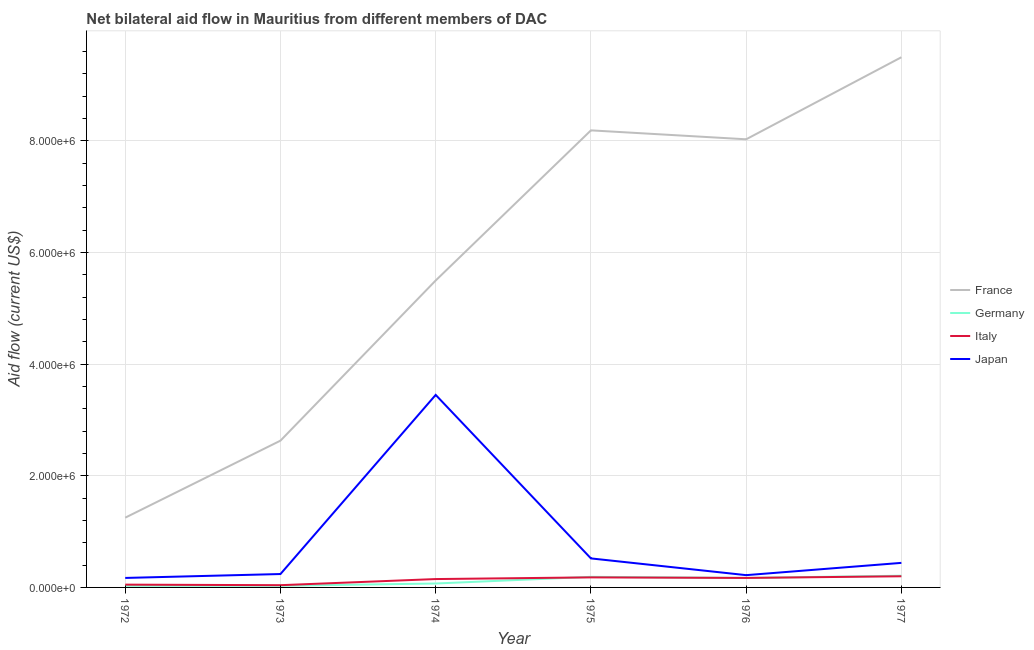How many different coloured lines are there?
Offer a very short reply. 4. What is the amount of aid given by france in 1974?
Your response must be concise. 5.50e+06. Across all years, what is the maximum amount of aid given by italy?
Your answer should be very brief. 2.00e+05. Across all years, what is the minimum amount of aid given by italy?
Your answer should be very brief. 4.00e+04. What is the total amount of aid given by france in the graph?
Ensure brevity in your answer.  3.51e+07. What is the difference between the amount of aid given by japan in 1972 and that in 1975?
Provide a short and direct response. -3.50e+05. What is the difference between the amount of aid given by italy in 1972 and the amount of aid given by germany in 1976?
Your answer should be compact. -1.20e+05. What is the average amount of aid given by germany per year?
Offer a very short reply. 1.17e+05. In the year 1973, what is the difference between the amount of aid given by germany and amount of aid given by italy?
Provide a succinct answer. -10000. In how many years, is the amount of aid given by germany greater than 6800000 US$?
Offer a very short reply. 0. What is the ratio of the amount of aid given by france in 1976 to that in 1977?
Ensure brevity in your answer.  0.85. Is the amount of aid given by france in 1976 less than that in 1977?
Keep it short and to the point. Yes. Is the difference between the amount of aid given by germany in 1972 and 1975 greater than the difference between the amount of aid given by japan in 1972 and 1975?
Keep it short and to the point. Yes. What is the difference between the highest and the second highest amount of aid given by france?
Offer a very short reply. 1.31e+06. What is the difference between the highest and the lowest amount of aid given by japan?
Make the answer very short. 3.28e+06. In how many years, is the amount of aid given by japan greater than the average amount of aid given by japan taken over all years?
Provide a succinct answer. 1. Is it the case that in every year, the sum of the amount of aid given by japan and amount of aid given by italy is greater than the sum of amount of aid given by france and amount of aid given by germany?
Offer a terse response. No. Is it the case that in every year, the sum of the amount of aid given by france and amount of aid given by germany is greater than the amount of aid given by italy?
Your response must be concise. Yes. Does the amount of aid given by italy monotonically increase over the years?
Keep it short and to the point. No. How many lines are there?
Ensure brevity in your answer.  4. How many years are there in the graph?
Provide a succinct answer. 6. Are the values on the major ticks of Y-axis written in scientific E-notation?
Your answer should be very brief. Yes. Does the graph contain any zero values?
Make the answer very short. No. Does the graph contain grids?
Give a very brief answer. Yes. How are the legend labels stacked?
Offer a terse response. Vertical. What is the title of the graph?
Ensure brevity in your answer.  Net bilateral aid flow in Mauritius from different members of DAC. What is the Aid flow (current US$) in France in 1972?
Keep it short and to the point. 1.25e+06. What is the Aid flow (current US$) in Germany in 1972?
Provide a short and direct response. 3.00e+04. What is the Aid flow (current US$) in Italy in 1972?
Make the answer very short. 5.00e+04. What is the Aid flow (current US$) of Japan in 1972?
Provide a succinct answer. 1.70e+05. What is the Aid flow (current US$) in France in 1973?
Make the answer very short. 2.63e+06. What is the Aid flow (current US$) in Germany in 1973?
Give a very brief answer. 3.00e+04. What is the Aid flow (current US$) in France in 1974?
Ensure brevity in your answer.  5.50e+06. What is the Aid flow (current US$) in Japan in 1974?
Give a very brief answer. 3.45e+06. What is the Aid flow (current US$) in France in 1975?
Your answer should be compact. 8.19e+06. What is the Aid flow (current US$) in Italy in 1975?
Offer a terse response. 1.80e+05. What is the Aid flow (current US$) in Japan in 1975?
Your response must be concise. 5.20e+05. What is the Aid flow (current US$) in France in 1976?
Provide a succinct answer. 8.03e+06. What is the Aid flow (current US$) in Japan in 1976?
Offer a very short reply. 2.20e+05. What is the Aid flow (current US$) in France in 1977?
Offer a terse response. 9.50e+06. What is the Aid flow (current US$) of Germany in 1977?
Ensure brevity in your answer.  2.10e+05. Across all years, what is the maximum Aid flow (current US$) of France?
Offer a terse response. 9.50e+06. Across all years, what is the maximum Aid flow (current US$) in Germany?
Make the answer very short. 2.10e+05. Across all years, what is the maximum Aid flow (current US$) in Italy?
Your answer should be very brief. 2.00e+05. Across all years, what is the maximum Aid flow (current US$) of Japan?
Provide a short and direct response. 3.45e+06. Across all years, what is the minimum Aid flow (current US$) of France?
Offer a terse response. 1.25e+06. Across all years, what is the minimum Aid flow (current US$) of Italy?
Offer a terse response. 4.00e+04. What is the total Aid flow (current US$) of France in the graph?
Provide a succinct answer. 3.51e+07. What is the total Aid flow (current US$) of Italy in the graph?
Make the answer very short. 7.90e+05. What is the total Aid flow (current US$) in Japan in the graph?
Provide a short and direct response. 5.04e+06. What is the difference between the Aid flow (current US$) of France in 1972 and that in 1973?
Keep it short and to the point. -1.38e+06. What is the difference between the Aid flow (current US$) in Italy in 1972 and that in 1973?
Make the answer very short. 10000. What is the difference between the Aid flow (current US$) in Japan in 1972 and that in 1973?
Make the answer very short. -7.00e+04. What is the difference between the Aid flow (current US$) of France in 1972 and that in 1974?
Your response must be concise. -4.25e+06. What is the difference between the Aid flow (current US$) of Japan in 1972 and that in 1974?
Ensure brevity in your answer.  -3.28e+06. What is the difference between the Aid flow (current US$) in France in 1972 and that in 1975?
Your answer should be compact. -6.94e+06. What is the difference between the Aid flow (current US$) in Japan in 1972 and that in 1975?
Offer a terse response. -3.50e+05. What is the difference between the Aid flow (current US$) of France in 1972 and that in 1976?
Provide a short and direct response. -6.78e+06. What is the difference between the Aid flow (current US$) of Germany in 1972 and that in 1976?
Offer a very short reply. -1.40e+05. What is the difference between the Aid flow (current US$) in Italy in 1972 and that in 1976?
Keep it short and to the point. -1.20e+05. What is the difference between the Aid flow (current US$) of France in 1972 and that in 1977?
Offer a very short reply. -8.25e+06. What is the difference between the Aid flow (current US$) in France in 1973 and that in 1974?
Your answer should be compact. -2.87e+06. What is the difference between the Aid flow (current US$) in Japan in 1973 and that in 1974?
Your answer should be very brief. -3.21e+06. What is the difference between the Aid flow (current US$) in France in 1973 and that in 1975?
Your answer should be compact. -5.56e+06. What is the difference between the Aid flow (current US$) in Japan in 1973 and that in 1975?
Offer a very short reply. -2.80e+05. What is the difference between the Aid flow (current US$) in France in 1973 and that in 1976?
Ensure brevity in your answer.  -5.40e+06. What is the difference between the Aid flow (current US$) of Italy in 1973 and that in 1976?
Offer a terse response. -1.30e+05. What is the difference between the Aid flow (current US$) in France in 1973 and that in 1977?
Ensure brevity in your answer.  -6.87e+06. What is the difference between the Aid flow (current US$) in Japan in 1973 and that in 1977?
Your answer should be compact. -2.00e+05. What is the difference between the Aid flow (current US$) in France in 1974 and that in 1975?
Offer a terse response. -2.69e+06. What is the difference between the Aid flow (current US$) of Germany in 1974 and that in 1975?
Keep it short and to the point. -1.20e+05. What is the difference between the Aid flow (current US$) of Japan in 1974 and that in 1975?
Keep it short and to the point. 2.93e+06. What is the difference between the Aid flow (current US$) of France in 1974 and that in 1976?
Your response must be concise. -2.53e+06. What is the difference between the Aid flow (current US$) in Germany in 1974 and that in 1976?
Provide a short and direct response. -1.00e+05. What is the difference between the Aid flow (current US$) in Japan in 1974 and that in 1976?
Provide a short and direct response. 3.23e+06. What is the difference between the Aid flow (current US$) in France in 1974 and that in 1977?
Provide a succinct answer. -4.00e+06. What is the difference between the Aid flow (current US$) of Italy in 1974 and that in 1977?
Provide a short and direct response. -5.00e+04. What is the difference between the Aid flow (current US$) in Japan in 1974 and that in 1977?
Give a very brief answer. 3.01e+06. What is the difference between the Aid flow (current US$) in France in 1975 and that in 1976?
Offer a terse response. 1.60e+05. What is the difference between the Aid flow (current US$) in Germany in 1975 and that in 1976?
Keep it short and to the point. 2.00e+04. What is the difference between the Aid flow (current US$) of Italy in 1975 and that in 1976?
Provide a short and direct response. 10000. What is the difference between the Aid flow (current US$) in France in 1975 and that in 1977?
Provide a succinct answer. -1.31e+06. What is the difference between the Aid flow (current US$) of Germany in 1975 and that in 1977?
Give a very brief answer. -2.00e+04. What is the difference between the Aid flow (current US$) in Italy in 1975 and that in 1977?
Your response must be concise. -2.00e+04. What is the difference between the Aid flow (current US$) in Japan in 1975 and that in 1977?
Offer a terse response. 8.00e+04. What is the difference between the Aid flow (current US$) of France in 1976 and that in 1977?
Keep it short and to the point. -1.47e+06. What is the difference between the Aid flow (current US$) of Germany in 1976 and that in 1977?
Your response must be concise. -4.00e+04. What is the difference between the Aid flow (current US$) in Italy in 1976 and that in 1977?
Give a very brief answer. -3.00e+04. What is the difference between the Aid flow (current US$) of Japan in 1976 and that in 1977?
Provide a short and direct response. -2.20e+05. What is the difference between the Aid flow (current US$) of France in 1972 and the Aid flow (current US$) of Germany in 1973?
Keep it short and to the point. 1.22e+06. What is the difference between the Aid flow (current US$) of France in 1972 and the Aid flow (current US$) of Italy in 1973?
Provide a succinct answer. 1.21e+06. What is the difference between the Aid flow (current US$) in France in 1972 and the Aid flow (current US$) in Japan in 1973?
Your answer should be very brief. 1.01e+06. What is the difference between the Aid flow (current US$) in Germany in 1972 and the Aid flow (current US$) in Japan in 1973?
Give a very brief answer. -2.10e+05. What is the difference between the Aid flow (current US$) of Italy in 1972 and the Aid flow (current US$) of Japan in 1973?
Ensure brevity in your answer.  -1.90e+05. What is the difference between the Aid flow (current US$) of France in 1972 and the Aid flow (current US$) of Germany in 1974?
Make the answer very short. 1.18e+06. What is the difference between the Aid flow (current US$) of France in 1972 and the Aid flow (current US$) of Italy in 1974?
Offer a terse response. 1.10e+06. What is the difference between the Aid flow (current US$) in France in 1972 and the Aid flow (current US$) in Japan in 1974?
Your answer should be very brief. -2.20e+06. What is the difference between the Aid flow (current US$) of Germany in 1972 and the Aid flow (current US$) of Japan in 1974?
Offer a very short reply. -3.42e+06. What is the difference between the Aid flow (current US$) in Italy in 1972 and the Aid flow (current US$) in Japan in 1974?
Provide a short and direct response. -3.40e+06. What is the difference between the Aid flow (current US$) of France in 1972 and the Aid flow (current US$) of Germany in 1975?
Offer a terse response. 1.06e+06. What is the difference between the Aid flow (current US$) in France in 1972 and the Aid flow (current US$) in Italy in 1975?
Keep it short and to the point. 1.07e+06. What is the difference between the Aid flow (current US$) in France in 1972 and the Aid flow (current US$) in Japan in 1975?
Your answer should be compact. 7.30e+05. What is the difference between the Aid flow (current US$) in Germany in 1972 and the Aid flow (current US$) in Italy in 1975?
Provide a succinct answer. -1.50e+05. What is the difference between the Aid flow (current US$) in Germany in 1972 and the Aid flow (current US$) in Japan in 1975?
Make the answer very short. -4.90e+05. What is the difference between the Aid flow (current US$) of Italy in 1972 and the Aid flow (current US$) of Japan in 1975?
Provide a succinct answer. -4.70e+05. What is the difference between the Aid flow (current US$) in France in 1972 and the Aid flow (current US$) in Germany in 1976?
Ensure brevity in your answer.  1.08e+06. What is the difference between the Aid flow (current US$) of France in 1972 and the Aid flow (current US$) of Italy in 1976?
Ensure brevity in your answer.  1.08e+06. What is the difference between the Aid flow (current US$) in France in 1972 and the Aid flow (current US$) in Japan in 1976?
Your answer should be compact. 1.03e+06. What is the difference between the Aid flow (current US$) of France in 1972 and the Aid flow (current US$) of Germany in 1977?
Give a very brief answer. 1.04e+06. What is the difference between the Aid flow (current US$) of France in 1972 and the Aid flow (current US$) of Italy in 1977?
Provide a short and direct response. 1.05e+06. What is the difference between the Aid flow (current US$) in France in 1972 and the Aid flow (current US$) in Japan in 1977?
Give a very brief answer. 8.10e+05. What is the difference between the Aid flow (current US$) in Germany in 1972 and the Aid flow (current US$) in Italy in 1977?
Your answer should be very brief. -1.70e+05. What is the difference between the Aid flow (current US$) in Germany in 1972 and the Aid flow (current US$) in Japan in 1977?
Keep it short and to the point. -4.10e+05. What is the difference between the Aid flow (current US$) of Italy in 1972 and the Aid flow (current US$) of Japan in 1977?
Offer a terse response. -3.90e+05. What is the difference between the Aid flow (current US$) of France in 1973 and the Aid flow (current US$) of Germany in 1974?
Keep it short and to the point. 2.56e+06. What is the difference between the Aid flow (current US$) in France in 1973 and the Aid flow (current US$) in Italy in 1974?
Provide a succinct answer. 2.48e+06. What is the difference between the Aid flow (current US$) of France in 1973 and the Aid flow (current US$) of Japan in 1974?
Give a very brief answer. -8.20e+05. What is the difference between the Aid flow (current US$) of Germany in 1973 and the Aid flow (current US$) of Italy in 1974?
Your answer should be very brief. -1.20e+05. What is the difference between the Aid flow (current US$) of Germany in 1973 and the Aid flow (current US$) of Japan in 1974?
Offer a terse response. -3.42e+06. What is the difference between the Aid flow (current US$) of Italy in 1973 and the Aid flow (current US$) of Japan in 1974?
Your answer should be very brief. -3.41e+06. What is the difference between the Aid flow (current US$) in France in 1973 and the Aid flow (current US$) in Germany in 1975?
Make the answer very short. 2.44e+06. What is the difference between the Aid flow (current US$) of France in 1973 and the Aid flow (current US$) of Italy in 1975?
Your answer should be compact. 2.45e+06. What is the difference between the Aid flow (current US$) in France in 1973 and the Aid flow (current US$) in Japan in 1975?
Ensure brevity in your answer.  2.11e+06. What is the difference between the Aid flow (current US$) of Germany in 1973 and the Aid flow (current US$) of Italy in 1975?
Provide a short and direct response. -1.50e+05. What is the difference between the Aid flow (current US$) in Germany in 1973 and the Aid flow (current US$) in Japan in 1975?
Your response must be concise. -4.90e+05. What is the difference between the Aid flow (current US$) in Italy in 1973 and the Aid flow (current US$) in Japan in 1975?
Give a very brief answer. -4.80e+05. What is the difference between the Aid flow (current US$) of France in 1973 and the Aid flow (current US$) of Germany in 1976?
Give a very brief answer. 2.46e+06. What is the difference between the Aid flow (current US$) of France in 1973 and the Aid flow (current US$) of Italy in 1976?
Keep it short and to the point. 2.46e+06. What is the difference between the Aid flow (current US$) in France in 1973 and the Aid flow (current US$) in Japan in 1976?
Keep it short and to the point. 2.41e+06. What is the difference between the Aid flow (current US$) in Germany in 1973 and the Aid flow (current US$) in Japan in 1976?
Offer a very short reply. -1.90e+05. What is the difference between the Aid flow (current US$) of France in 1973 and the Aid flow (current US$) of Germany in 1977?
Your response must be concise. 2.42e+06. What is the difference between the Aid flow (current US$) in France in 1973 and the Aid flow (current US$) in Italy in 1977?
Keep it short and to the point. 2.43e+06. What is the difference between the Aid flow (current US$) in France in 1973 and the Aid flow (current US$) in Japan in 1977?
Offer a terse response. 2.19e+06. What is the difference between the Aid flow (current US$) in Germany in 1973 and the Aid flow (current US$) in Japan in 1977?
Provide a short and direct response. -4.10e+05. What is the difference between the Aid flow (current US$) in Italy in 1973 and the Aid flow (current US$) in Japan in 1977?
Make the answer very short. -4.00e+05. What is the difference between the Aid flow (current US$) of France in 1974 and the Aid flow (current US$) of Germany in 1975?
Offer a terse response. 5.31e+06. What is the difference between the Aid flow (current US$) in France in 1974 and the Aid flow (current US$) in Italy in 1975?
Your answer should be compact. 5.32e+06. What is the difference between the Aid flow (current US$) of France in 1974 and the Aid flow (current US$) of Japan in 1975?
Provide a succinct answer. 4.98e+06. What is the difference between the Aid flow (current US$) of Germany in 1974 and the Aid flow (current US$) of Italy in 1975?
Keep it short and to the point. -1.10e+05. What is the difference between the Aid flow (current US$) in Germany in 1974 and the Aid flow (current US$) in Japan in 1975?
Give a very brief answer. -4.50e+05. What is the difference between the Aid flow (current US$) in Italy in 1974 and the Aid flow (current US$) in Japan in 1975?
Provide a succinct answer. -3.70e+05. What is the difference between the Aid flow (current US$) in France in 1974 and the Aid flow (current US$) in Germany in 1976?
Give a very brief answer. 5.33e+06. What is the difference between the Aid flow (current US$) of France in 1974 and the Aid flow (current US$) of Italy in 1976?
Make the answer very short. 5.33e+06. What is the difference between the Aid flow (current US$) in France in 1974 and the Aid flow (current US$) in Japan in 1976?
Your answer should be compact. 5.28e+06. What is the difference between the Aid flow (current US$) in Germany in 1974 and the Aid flow (current US$) in Japan in 1976?
Keep it short and to the point. -1.50e+05. What is the difference between the Aid flow (current US$) in France in 1974 and the Aid flow (current US$) in Germany in 1977?
Keep it short and to the point. 5.29e+06. What is the difference between the Aid flow (current US$) in France in 1974 and the Aid flow (current US$) in Italy in 1977?
Your response must be concise. 5.30e+06. What is the difference between the Aid flow (current US$) in France in 1974 and the Aid flow (current US$) in Japan in 1977?
Keep it short and to the point. 5.06e+06. What is the difference between the Aid flow (current US$) of Germany in 1974 and the Aid flow (current US$) of Italy in 1977?
Keep it short and to the point. -1.30e+05. What is the difference between the Aid flow (current US$) in Germany in 1974 and the Aid flow (current US$) in Japan in 1977?
Provide a short and direct response. -3.70e+05. What is the difference between the Aid flow (current US$) of France in 1975 and the Aid flow (current US$) of Germany in 1976?
Ensure brevity in your answer.  8.02e+06. What is the difference between the Aid flow (current US$) of France in 1975 and the Aid flow (current US$) of Italy in 1976?
Ensure brevity in your answer.  8.02e+06. What is the difference between the Aid flow (current US$) in France in 1975 and the Aid flow (current US$) in Japan in 1976?
Your answer should be very brief. 7.97e+06. What is the difference between the Aid flow (current US$) of Germany in 1975 and the Aid flow (current US$) of Italy in 1976?
Provide a succinct answer. 2.00e+04. What is the difference between the Aid flow (current US$) in Germany in 1975 and the Aid flow (current US$) in Japan in 1976?
Make the answer very short. -3.00e+04. What is the difference between the Aid flow (current US$) in France in 1975 and the Aid flow (current US$) in Germany in 1977?
Give a very brief answer. 7.98e+06. What is the difference between the Aid flow (current US$) in France in 1975 and the Aid flow (current US$) in Italy in 1977?
Make the answer very short. 7.99e+06. What is the difference between the Aid flow (current US$) in France in 1975 and the Aid flow (current US$) in Japan in 1977?
Your answer should be very brief. 7.75e+06. What is the difference between the Aid flow (current US$) of Germany in 1975 and the Aid flow (current US$) of Japan in 1977?
Keep it short and to the point. -2.50e+05. What is the difference between the Aid flow (current US$) of Italy in 1975 and the Aid flow (current US$) of Japan in 1977?
Your answer should be compact. -2.60e+05. What is the difference between the Aid flow (current US$) of France in 1976 and the Aid flow (current US$) of Germany in 1977?
Keep it short and to the point. 7.82e+06. What is the difference between the Aid flow (current US$) of France in 1976 and the Aid flow (current US$) of Italy in 1977?
Your answer should be very brief. 7.83e+06. What is the difference between the Aid flow (current US$) of France in 1976 and the Aid flow (current US$) of Japan in 1977?
Offer a terse response. 7.59e+06. What is the difference between the Aid flow (current US$) of Germany in 1976 and the Aid flow (current US$) of Italy in 1977?
Offer a very short reply. -3.00e+04. What is the difference between the Aid flow (current US$) in Germany in 1976 and the Aid flow (current US$) in Japan in 1977?
Offer a very short reply. -2.70e+05. What is the average Aid flow (current US$) in France per year?
Offer a terse response. 5.85e+06. What is the average Aid flow (current US$) of Germany per year?
Your response must be concise. 1.17e+05. What is the average Aid flow (current US$) in Italy per year?
Your response must be concise. 1.32e+05. What is the average Aid flow (current US$) in Japan per year?
Your response must be concise. 8.40e+05. In the year 1972, what is the difference between the Aid flow (current US$) in France and Aid flow (current US$) in Germany?
Offer a very short reply. 1.22e+06. In the year 1972, what is the difference between the Aid flow (current US$) of France and Aid flow (current US$) of Italy?
Make the answer very short. 1.20e+06. In the year 1972, what is the difference between the Aid flow (current US$) in France and Aid flow (current US$) in Japan?
Keep it short and to the point. 1.08e+06. In the year 1973, what is the difference between the Aid flow (current US$) of France and Aid flow (current US$) of Germany?
Your response must be concise. 2.60e+06. In the year 1973, what is the difference between the Aid flow (current US$) of France and Aid flow (current US$) of Italy?
Provide a short and direct response. 2.59e+06. In the year 1973, what is the difference between the Aid flow (current US$) in France and Aid flow (current US$) in Japan?
Offer a very short reply. 2.39e+06. In the year 1973, what is the difference between the Aid flow (current US$) in Germany and Aid flow (current US$) in Japan?
Your answer should be very brief. -2.10e+05. In the year 1973, what is the difference between the Aid flow (current US$) in Italy and Aid flow (current US$) in Japan?
Provide a short and direct response. -2.00e+05. In the year 1974, what is the difference between the Aid flow (current US$) in France and Aid flow (current US$) in Germany?
Provide a short and direct response. 5.43e+06. In the year 1974, what is the difference between the Aid flow (current US$) in France and Aid flow (current US$) in Italy?
Give a very brief answer. 5.35e+06. In the year 1974, what is the difference between the Aid flow (current US$) in France and Aid flow (current US$) in Japan?
Offer a very short reply. 2.05e+06. In the year 1974, what is the difference between the Aid flow (current US$) of Germany and Aid flow (current US$) of Italy?
Your answer should be very brief. -8.00e+04. In the year 1974, what is the difference between the Aid flow (current US$) of Germany and Aid flow (current US$) of Japan?
Offer a very short reply. -3.38e+06. In the year 1974, what is the difference between the Aid flow (current US$) in Italy and Aid flow (current US$) in Japan?
Ensure brevity in your answer.  -3.30e+06. In the year 1975, what is the difference between the Aid flow (current US$) of France and Aid flow (current US$) of Italy?
Give a very brief answer. 8.01e+06. In the year 1975, what is the difference between the Aid flow (current US$) of France and Aid flow (current US$) of Japan?
Provide a short and direct response. 7.67e+06. In the year 1975, what is the difference between the Aid flow (current US$) of Germany and Aid flow (current US$) of Japan?
Your answer should be compact. -3.30e+05. In the year 1976, what is the difference between the Aid flow (current US$) in France and Aid flow (current US$) in Germany?
Keep it short and to the point. 7.86e+06. In the year 1976, what is the difference between the Aid flow (current US$) of France and Aid flow (current US$) of Italy?
Give a very brief answer. 7.86e+06. In the year 1976, what is the difference between the Aid flow (current US$) in France and Aid flow (current US$) in Japan?
Provide a short and direct response. 7.81e+06. In the year 1976, what is the difference between the Aid flow (current US$) in Germany and Aid flow (current US$) in Italy?
Offer a very short reply. 0. In the year 1976, what is the difference between the Aid flow (current US$) in Italy and Aid flow (current US$) in Japan?
Provide a succinct answer. -5.00e+04. In the year 1977, what is the difference between the Aid flow (current US$) in France and Aid flow (current US$) in Germany?
Ensure brevity in your answer.  9.29e+06. In the year 1977, what is the difference between the Aid flow (current US$) in France and Aid flow (current US$) in Italy?
Offer a very short reply. 9.30e+06. In the year 1977, what is the difference between the Aid flow (current US$) in France and Aid flow (current US$) in Japan?
Offer a very short reply. 9.06e+06. In the year 1977, what is the difference between the Aid flow (current US$) in Germany and Aid flow (current US$) in Italy?
Your answer should be compact. 10000. In the year 1977, what is the difference between the Aid flow (current US$) in Germany and Aid flow (current US$) in Japan?
Ensure brevity in your answer.  -2.30e+05. In the year 1977, what is the difference between the Aid flow (current US$) in Italy and Aid flow (current US$) in Japan?
Offer a very short reply. -2.40e+05. What is the ratio of the Aid flow (current US$) of France in 1972 to that in 1973?
Offer a very short reply. 0.48. What is the ratio of the Aid flow (current US$) in Japan in 1972 to that in 1973?
Offer a terse response. 0.71. What is the ratio of the Aid flow (current US$) in France in 1972 to that in 1974?
Provide a short and direct response. 0.23. What is the ratio of the Aid flow (current US$) of Germany in 1972 to that in 1974?
Your response must be concise. 0.43. What is the ratio of the Aid flow (current US$) in Italy in 1972 to that in 1974?
Ensure brevity in your answer.  0.33. What is the ratio of the Aid flow (current US$) of Japan in 1972 to that in 1974?
Your response must be concise. 0.05. What is the ratio of the Aid flow (current US$) of France in 1972 to that in 1975?
Provide a succinct answer. 0.15. What is the ratio of the Aid flow (current US$) in Germany in 1972 to that in 1975?
Ensure brevity in your answer.  0.16. What is the ratio of the Aid flow (current US$) of Italy in 1972 to that in 1975?
Offer a very short reply. 0.28. What is the ratio of the Aid flow (current US$) in Japan in 1972 to that in 1975?
Make the answer very short. 0.33. What is the ratio of the Aid flow (current US$) in France in 1972 to that in 1976?
Offer a very short reply. 0.16. What is the ratio of the Aid flow (current US$) in Germany in 1972 to that in 1976?
Offer a terse response. 0.18. What is the ratio of the Aid flow (current US$) of Italy in 1972 to that in 1976?
Make the answer very short. 0.29. What is the ratio of the Aid flow (current US$) in Japan in 1972 to that in 1976?
Offer a very short reply. 0.77. What is the ratio of the Aid flow (current US$) of France in 1972 to that in 1977?
Ensure brevity in your answer.  0.13. What is the ratio of the Aid flow (current US$) of Germany in 1972 to that in 1977?
Keep it short and to the point. 0.14. What is the ratio of the Aid flow (current US$) in Italy in 1972 to that in 1977?
Make the answer very short. 0.25. What is the ratio of the Aid flow (current US$) in Japan in 1972 to that in 1977?
Provide a short and direct response. 0.39. What is the ratio of the Aid flow (current US$) of France in 1973 to that in 1974?
Your answer should be compact. 0.48. What is the ratio of the Aid flow (current US$) of Germany in 1973 to that in 1974?
Offer a terse response. 0.43. What is the ratio of the Aid flow (current US$) of Italy in 1973 to that in 1974?
Provide a short and direct response. 0.27. What is the ratio of the Aid flow (current US$) of Japan in 1973 to that in 1974?
Offer a terse response. 0.07. What is the ratio of the Aid flow (current US$) in France in 1973 to that in 1975?
Ensure brevity in your answer.  0.32. What is the ratio of the Aid flow (current US$) in Germany in 1973 to that in 1975?
Offer a very short reply. 0.16. What is the ratio of the Aid flow (current US$) in Italy in 1973 to that in 1975?
Make the answer very short. 0.22. What is the ratio of the Aid flow (current US$) in Japan in 1973 to that in 1975?
Keep it short and to the point. 0.46. What is the ratio of the Aid flow (current US$) in France in 1973 to that in 1976?
Offer a very short reply. 0.33. What is the ratio of the Aid flow (current US$) in Germany in 1973 to that in 1976?
Your response must be concise. 0.18. What is the ratio of the Aid flow (current US$) in Italy in 1973 to that in 1976?
Make the answer very short. 0.24. What is the ratio of the Aid flow (current US$) of Japan in 1973 to that in 1976?
Make the answer very short. 1.09. What is the ratio of the Aid flow (current US$) in France in 1973 to that in 1977?
Give a very brief answer. 0.28. What is the ratio of the Aid flow (current US$) of Germany in 1973 to that in 1977?
Provide a succinct answer. 0.14. What is the ratio of the Aid flow (current US$) of Italy in 1973 to that in 1977?
Offer a very short reply. 0.2. What is the ratio of the Aid flow (current US$) of Japan in 1973 to that in 1977?
Give a very brief answer. 0.55. What is the ratio of the Aid flow (current US$) of France in 1974 to that in 1975?
Provide a succinct answer. 0.67. What is the ratio of the Aid flow (current US$) of Germany in 1974 to that in 1975?
Provide a short and direct response. 0.37. What is the ratio of the Aid flow (current US$) in Japan in 1974 to that in 1975?
Keep it short and to the point. 6.63. What is the ratio of the Aid flow (current US$) of France in 1974 to that in 1976?
Give a very brief answer. 0.68. What is the ratio of the Aid flow (current US$) in Germany in 1974 to that in 1976?
Provide a succinct answer. 0.41. What is the ratio of the Aid flow (current US$) in Italy in 1974 to that in 1976?
Ensure brevity in your answer.  0.88. What is the ratio of the Aid flow (current US$) of Japan in 1974 to that in 1976?
Your answer should be very brief. 15.68. What is the ratio of the Aid flow (current US$) in France in 1974 to that in 1977?
Offer a terse response. 0.58. What is the ratio of the Aid flow (current US$) in Germany in 1974 to that in 1977?
Your response must be concise. 0.33. What is the ratio of the Aid flow (current US$) of Italy in 1974 to that in 1977?
Your answer should be very brief. 0.75. What is the ratio of the Aid flow (current US$) in Japan in 1974 to that in 1977?
Keep it short and to the point. 7.84. What is the ratio of the Aid flow (current US$) of France in 1975 to that in 1976?
Provide a short and direct response. 1.02. What is the ratio of the Aid flow (current US$) of Germany in 1975 to that in 1976?
Make the answer very short. 1.12. What is the ratio of the Aid flow (current US$) in Italy in 1975 to that in 1976?
Your response must be concise. 1.06. What is the ratio of the Aid flow (current US$) in Japan in 1975 to that in 1976?
Provide a succinct answer. 2.36. What is the ratio of the Aid flow (current US$) of France in 1975 to that in 1977?
Provide a succinct answer. 0.86. What is the ratio of the Aid flow (current US$) in Germany in 1975 to that in 1977?
Your response must be concise. 0.9. What is the ratio of the Aid flow (current US$) of Japan in 1975 to that in 1977?
Keep it short and to the point. 1.18. What is the ratio of the Aid flow (current US$) in France in 1976 to that in 1977?
Provide a short and direct response. 0.85. What is the ratio of the Aid flow (current US$) of Germany in 1976 to that in 1977?
Ensure brevity in your answer.  0.81. What is the ratio of the Aid flow (current US$) of Japan in 1976 to that in 1977?
Give a very brief answer. 0.5. What is the difference between the highest and the second highest Aid flow (current US$) in France?
Provide a short and direct response. 1.31e+06. What is the difference between the highest and the second highest Aid flow (current US$) of Germany?
Provide a short and direct response. 2.00e+04. What is the difference between the highest and the second highest Aid flow (current US$) of Japan?
Your answer should be very brief. 2.93e+06. What is the difference between the highest and the lowest Aid flow (current US$) of France?
Ensure brevity in your answer.  8.25e+06. What is the difference between the highest and the lowest Aid flow (current US$) of Italy?
Provide a short and direct response. 1.60e+05. What is the difference between the highest and the lowest Aid flow (current US$) in Japan?
Keep it short and to the point. 3.28e+06. 